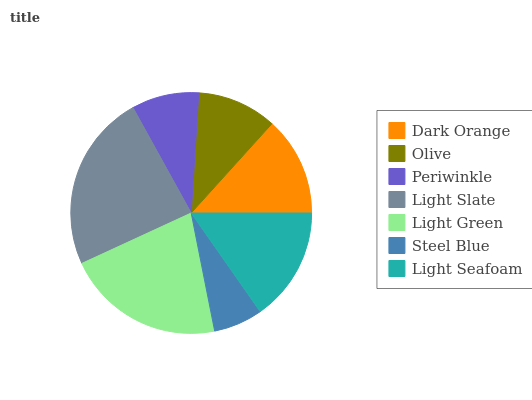Is Steel Blue the minimum?
Answer yes or no. Yes. Is Light Slate the maximum?
Answer yes or no. Yes. Is Olive the minimum?
Answer yes or no. No. Is Olive the maximum?
Answer yes or no. No. Is Dark Orange greater than Olive?
Answer yes or no. Yes. Is Olive less than Dark Orange?
Answer yes or no. Yes. Is Olive greater than Dark Orange?
Answer yes or no. No. Is Dark Orange less than Olive?
Answer yes or no. No. Is Dark Orange the high median?
Answer yes or no. Yes. Is Dark Orange the low median?
Answer yes or no. Yes. Is Olive the high median?
Answer yes or no. No. Is Steel Blue the low median?
Answer yes or no. No. 